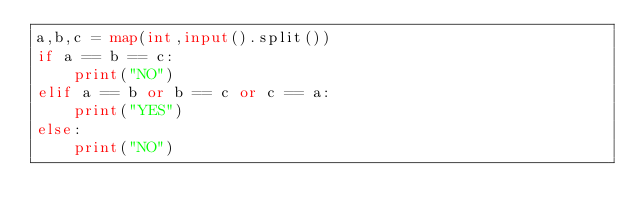Convert code to text. <code><loc_0><loc_0><loc_500><loc_500><_Python_>a,b,c = map(int,input().split())
if a == b == c:
    print("NO")
elif a == b or b == c or c == a:
    print("YES")
else:
    print("NO")</code> 